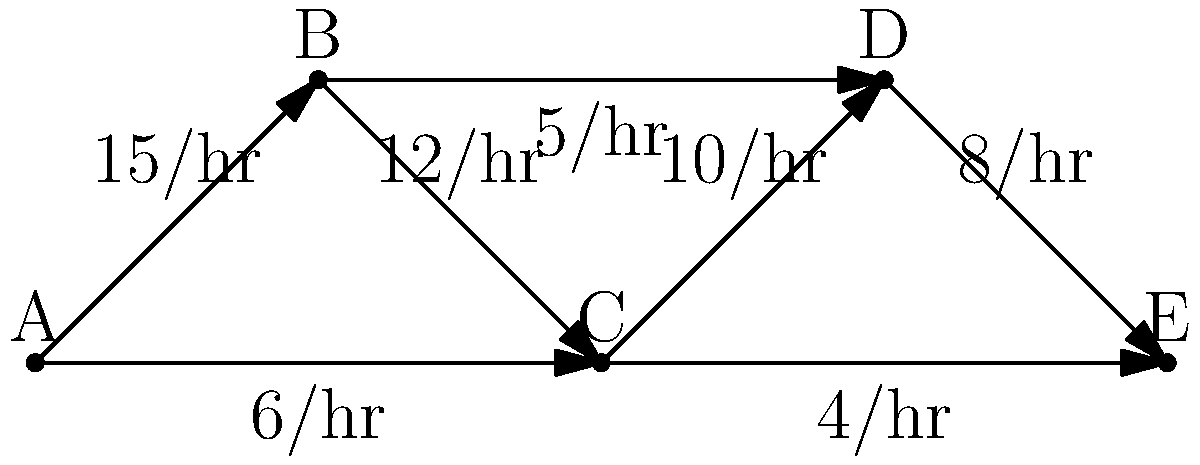Given the network diagram representing public transportation routes between five urban centers (A, B, C, D, and E) with their respective hourly frequencies, which route would be most beneficial to improve in terms of frequency to enhance overall connectivity and reduce travel times between the outermost points (A and E)? To determine which route would be most beneficial to improve, we need to analyze the network and consider the following steps:

1. Identify the possible paths from A to E:
   - A → B → C → D → E
   - A → C → D → E
   - A → C → E

2. Calculate the total frequency for each path:
   - Path 1: $\frac{1}{15} + \frac{1}{12} + \frac{1}{10} + \frac{1}{8} = 0.458$ hours
   - Path 2: $\frac{1}{6} + \frac{1}{10} + \frac{1}{8} = 0.458$ hours
   - Path 3: $\frac{1}{6} + \frac{1}{4} = 0.417$ hours

3. Identify the critical route:
   The route C → E has the lowest frequency (4/hr) and is part of the fastest path (Path 3).

4. Analyze the impact of improving C → E:
   Increasing the frequency of C → E would significantly reduce travel time on the fastest path and improve overall connectivity between A and E.

5. Consider alternative improvements:
   Improving A → C (6/hr) could also be beneficial, but it would have less impact on the overall network as it's already part of the fastest path.

6. Evaluate the urban planning perspective:
   As a practical urban planner, improving C → E would likely be more cost-effective and have a greater impact on the entire network, as it connects three urban centers (C, D, and E) rather than just two.

Therefore, improving the frequency of the route between C and E would be most beneficial for enhancing overall connectivity and reducing travel times between A and E.
Answer: C → E route 